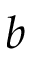<formula> <loc_0><loc_0><loc_500><loc_500>b</formula> 